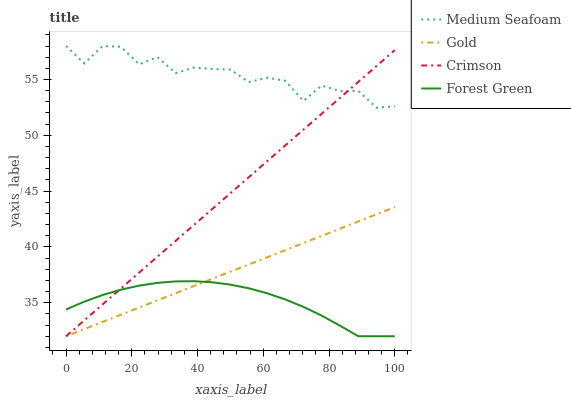Does Forest Green have the minimum area under the curve?
Answer yes or no. Yes. Does Medium Seafoam have the maximum area under the curve?
Answer yes or no. Yes. Does Medium Seafoam have the minimum area under the curve?
Answer yes or no. No. Does Forest Green have the maximum area under the curve?
Answer yes or no. No. Is Crimson the smoothest?
Answer yes or no. Yes. Is Medium Seafoam the roughest?
Answer yes or no. Yes. Is Forest Green the smoothest?
Answer yes or no. No. Is Forest Green the roughest?
Answer yes or no. No. Does Crimson have the lowest value?
Answer yes or no. Yes. Does Medium Seafoam have the lowest value?
Answer yes or no. No. Does Medium Seafoam have the highest value?
Answer yes or no. Yes. Does Forest Green have the highest value?
Answer yes or no. No. Is Gold less than Medium Seafoam?
Answer yes or no. Yes. Is Medium Seafoam greater than Forest Green?
Answer yes or no. Yes. Does Crimson intersect Forest Green?
Answer yes or no. Yes. Is Crimson less than Forest Green?
Answer yes or no. No. Is Crimson greater than Forest Green?
Answer yes or no. No. Does Gold intersect Medium Seafoam?
Answer yes or no. No. 